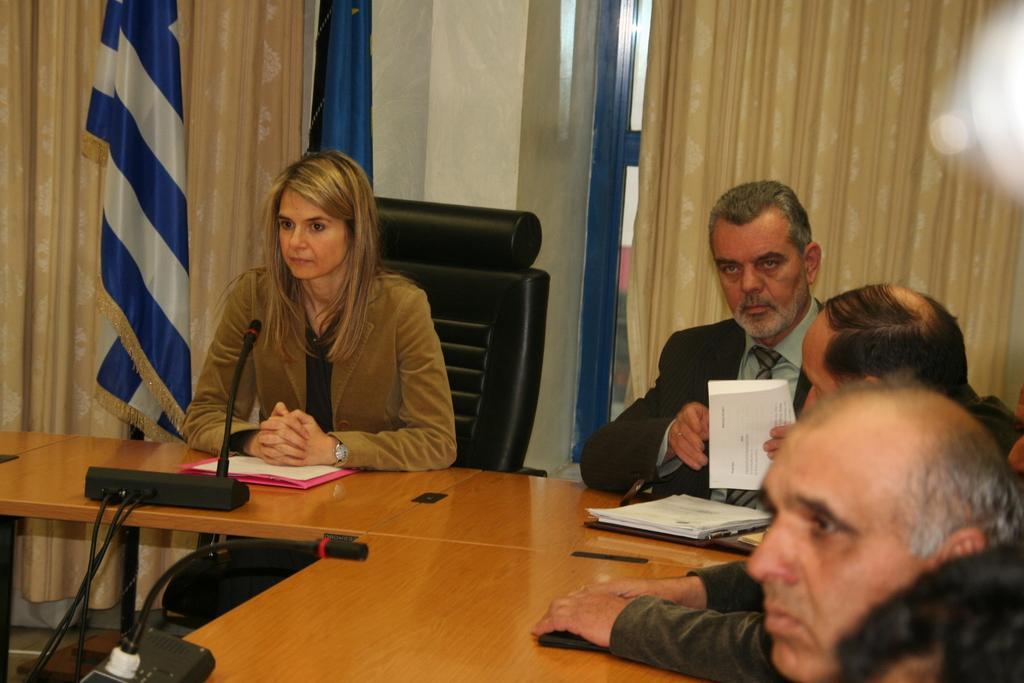In one or two sentences, can you explain what this image depicts? In this image we can see some people sitting on the chairs beside a table containing some papers, filed, a mic with a stand, some wires and a device on it. We can also see a man holding a paper. On the backside we can see the curtains, a wall and the flags. 